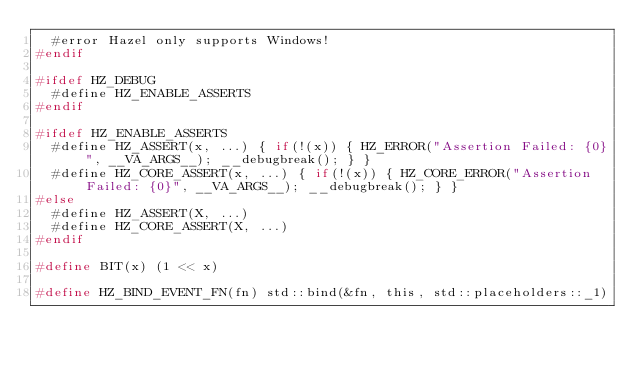Convert code to text. <code><loc_0><loc_0><loc_500><loc_500><_C_>	#error Hazel only supports Windows!
#endif

#ifdef HZ_DEBUG
	#define HZ_ENABLE_ASSERTS
#endif

#ifdef HZ_ENABLE_ASSERTS
	#define HZ_ASSERT(x, ...) { if(!(x)) { HZ_ERROR("Assertion Failed: {0}", __VA_ARGS__); __debugbreak(); } }
	#define HZ_CORE_ASSERT(x, ...) { if(!(x)) { HZ_CORE_ERROR("Assertion Failed: {0}", __VA_ARGS__); __debugbreak(); } }
#else
	#define HZ_ASSERT(X, ...)
	#define HZ_CORE_ASSERT(X, ...)
#endif

#define BIT(x) (1 << x)

#define HZ_BIND_EVENT_FN(fn) std::bind(&fn, this, std::placeholders::_1)</code> 